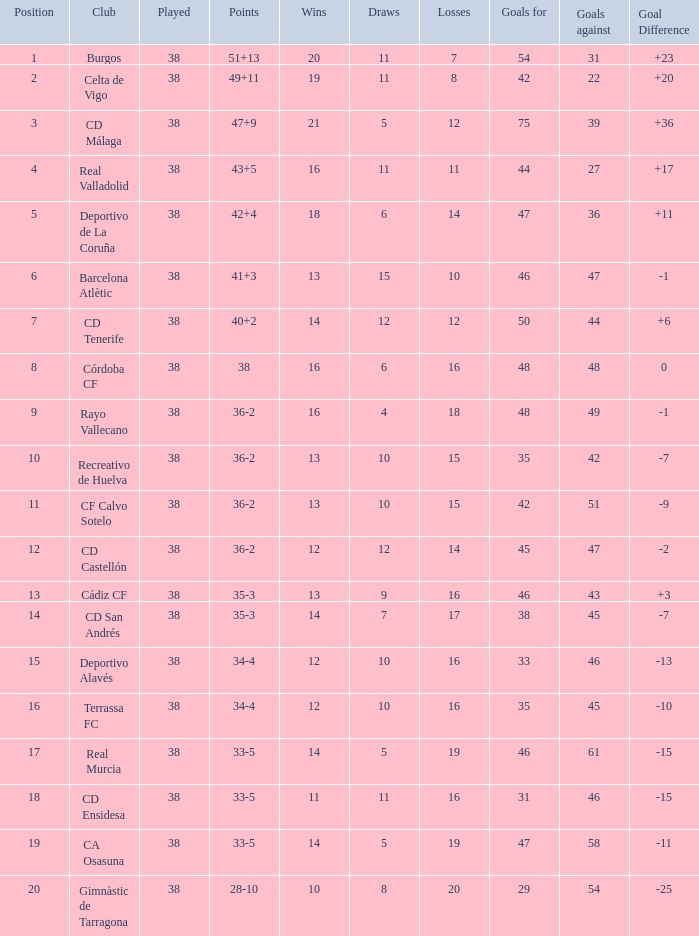Which rank is the highest with fewer than 54 goals scored, 7 losses, and a goal difference greater than 23? None. 